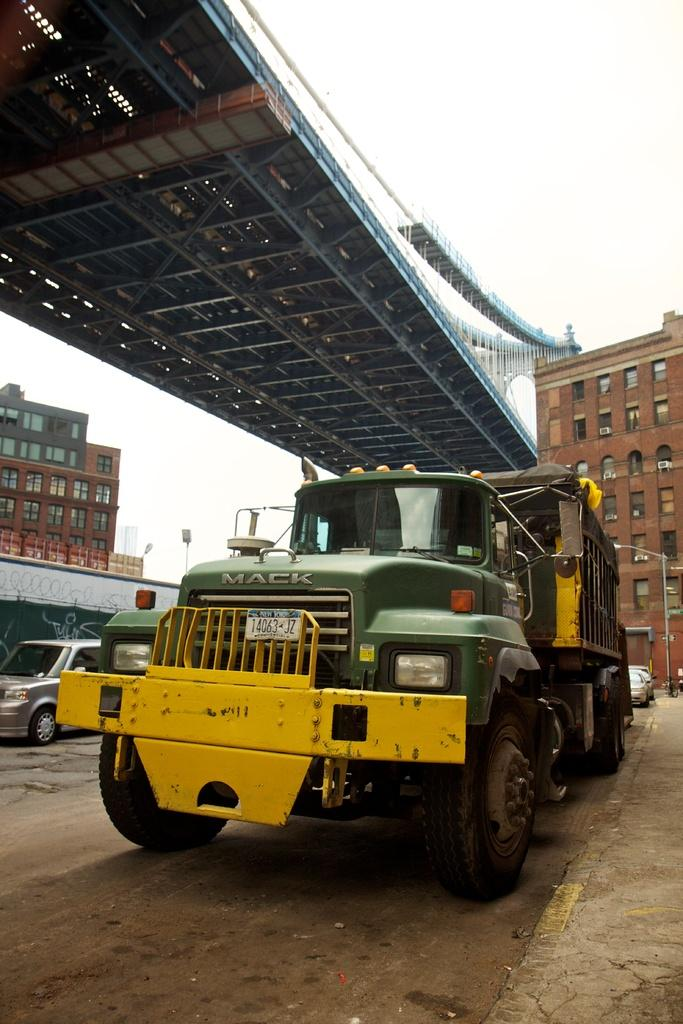<image>
Provide a brief description of the given image. A green Mack truck parked along the side of a road 